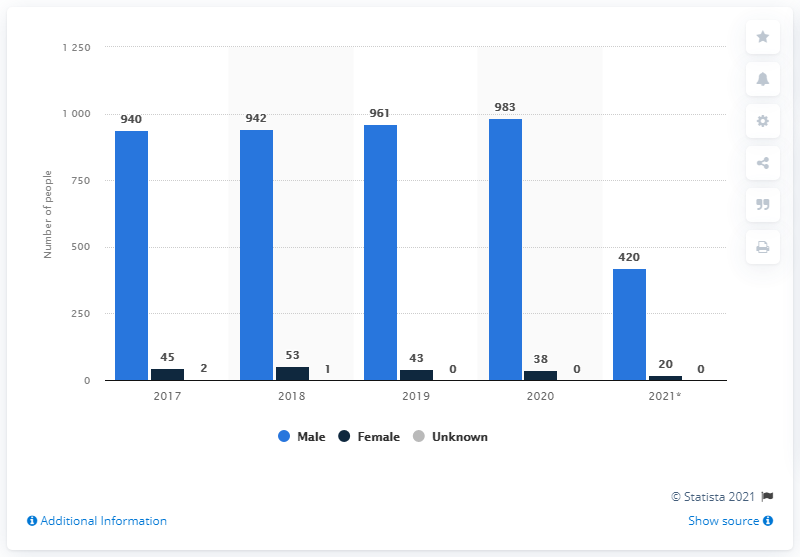Point out several critical features in this image. The number of people shot to death by police in the US was increasing over the years until 2020, with male individuals being disproportionately affected. The gender with invisible bars in the graph is unknown. In 2020, a total of 983 individuals, consisting of 595 men and 388 women, were shot to death by the police. In 2021, a total of 420 men were shot and killed by US police. 